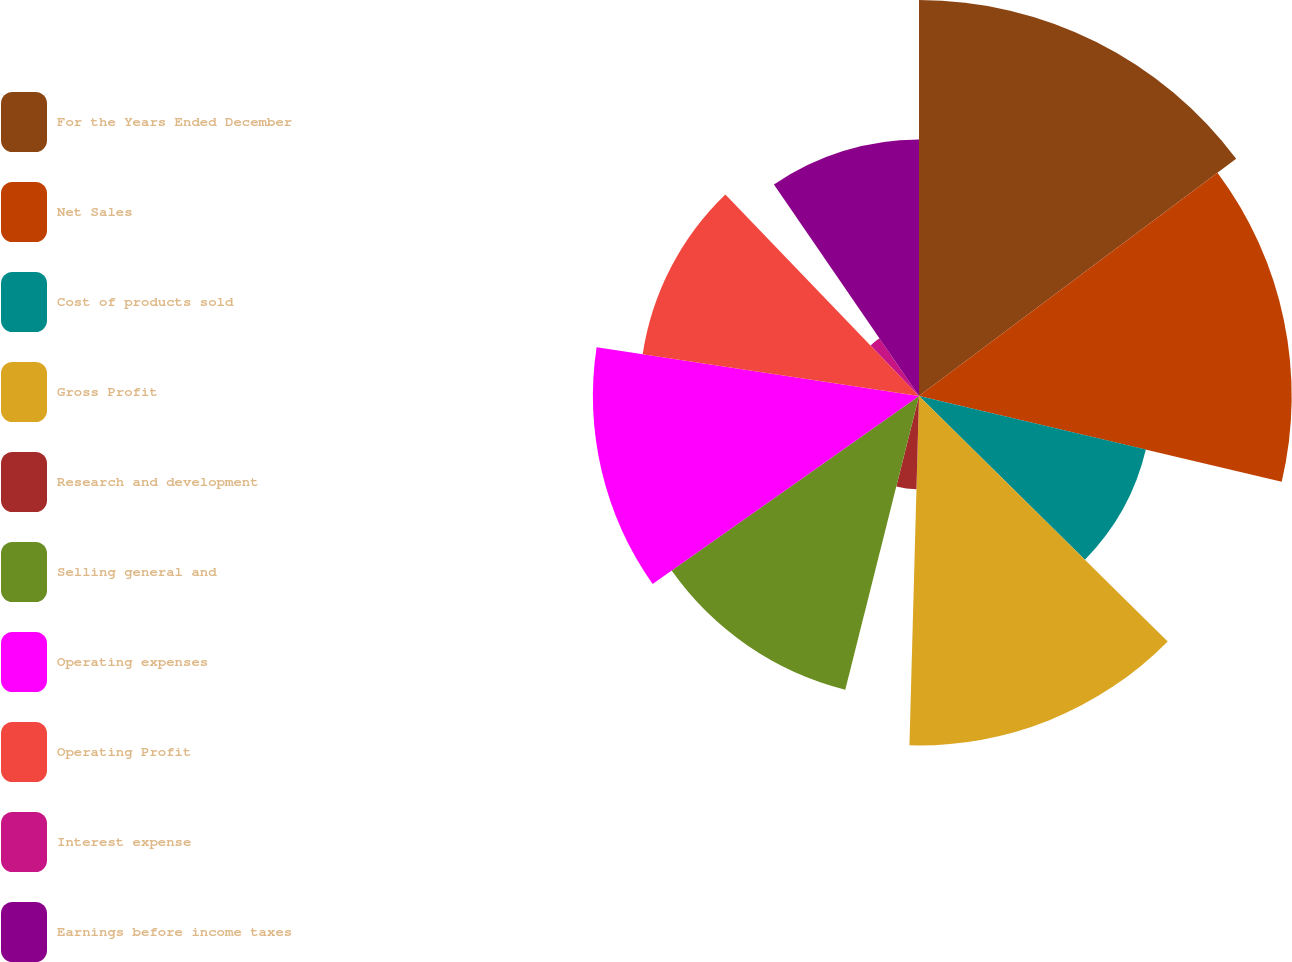<chart> <loc_0><loc_0><loc_500><loc_500><pie_chart><fcel>For the Years Ended December<fcel>Net Sales<fcel>Cost of products sold<fcel>Gross Profit<fcel>Research and development<fcel>Selling general and<fcel>Operating expenses<fcel>Operating Profit<fcel>Interest expense<fcel>Earnings before income taxes<nl><fcel>14.78%<fcel>13.91%<fcel>8.7%<fcel>13.04%<fcel>3.48%<fcel>11.3%<fcel>12.17%<fcel>10.43%<fcel>2.61%<fcel>9.57%<nl></chart> 